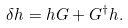Convert formula to latex. <formula><loc_0><loc_0><loc_500><loc_500>\delta h = h G + G ^ { \dagger } h .</formula> 